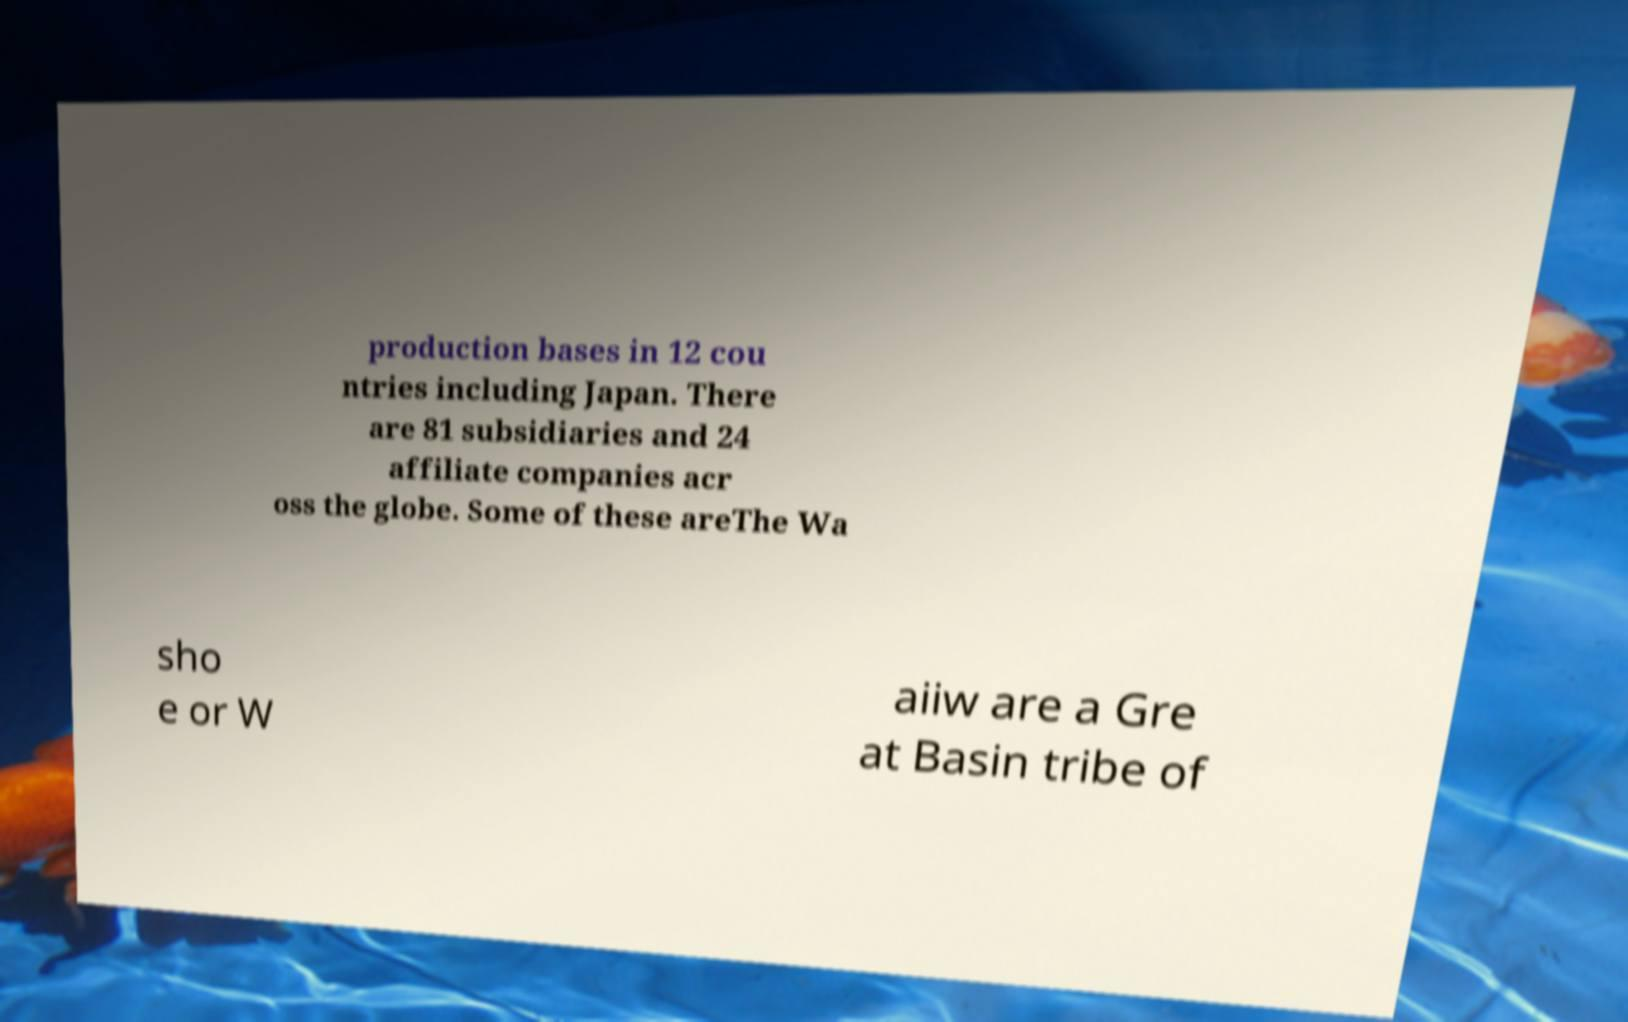What messages or text are displayed in this image? I need them in a readable, typed format. production bases in 12 cou ntries including Japan. There are 81 subsidiaries and 24 affiliate companies acr oss the globe. Some of these areThe Wa sho e or W aiiw are a Gre at Basin tribe of 